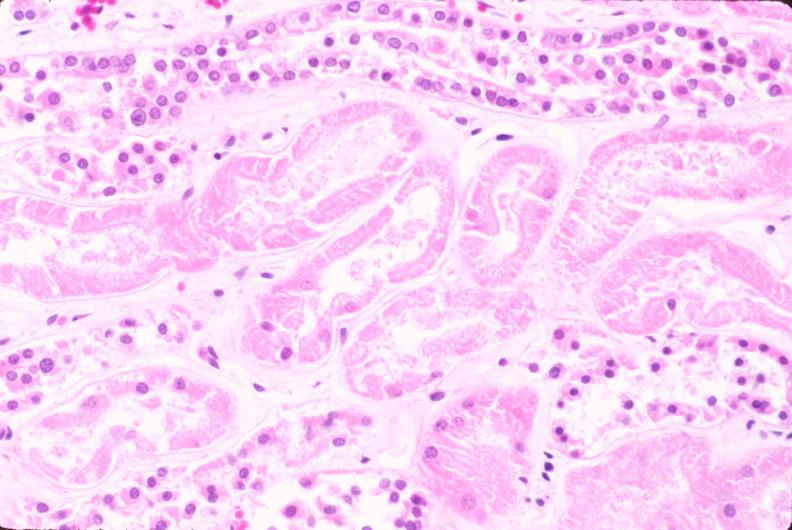where is this?
Answer the question using a single word or phrase. Urinary 